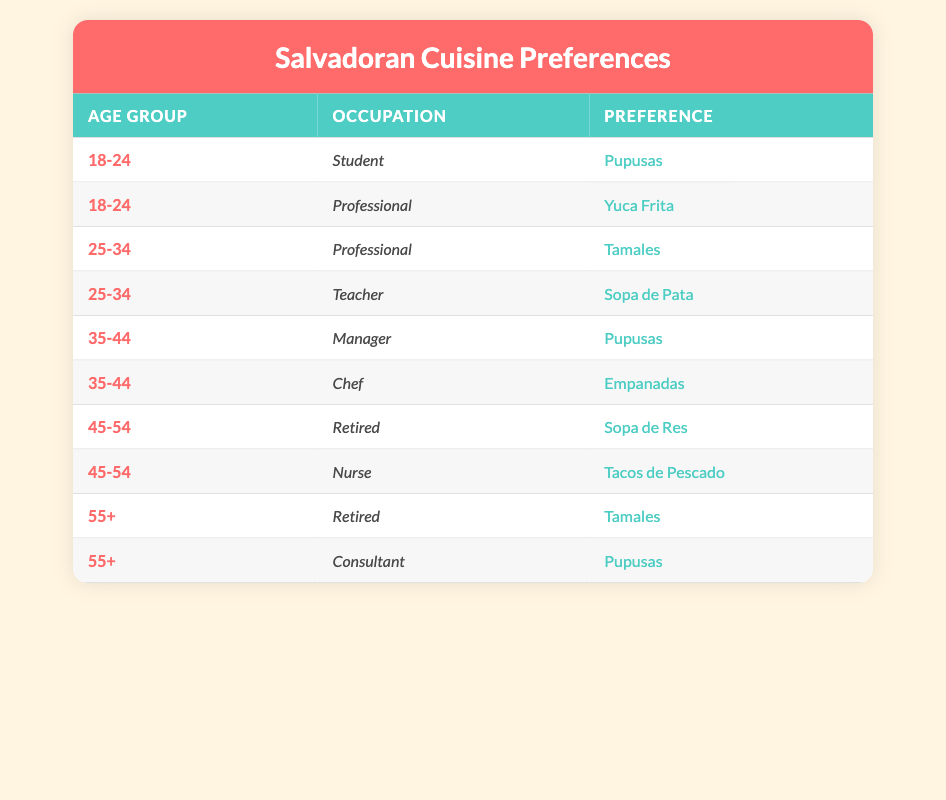What is the most preferred dish among customers aged 35-44? Looking at the preferences listed for the age group 35-44, the dishes are Pupusas and Empanadas. Among these, Pupusas appears first. Therefore, the most preferred dish in this age group is Pupusas.
Answer: Pupusas How many customers aged 55+ prefer Pupusas? In the age group 55+, there are two preferences listed: Tamales and Pupusas. Only one customer, a Consultant, has listed Pupusas as their preference. Hence, there is one customer who prefers Pupusas in this age group.
Answer: 1 Which occupation is associated with Sopa de Res? The occupation associated with Sopa de Res can be found in the table under the age group 45-54. A Retired individual prefers Sopa de Res. Therefore, the occupation related to this dish is Retired.
Answer: Retired Are there any students who prefer Yuca Frita? The table shows that one student aged 18-24 prefers Pupusas and there are no mentions of students preferring Yuca Frita. Thus, there are no students who prefer Yuca Frita.
Answer: No Which age group shows the highest variety of preferences? To find the age group with the highest variety of preferences, we look at the number of different dishes listed in each group: 18-24 has 2, 25-34 has 2, 35-44 has 2, 45-54 has 2, and 55+ has 2. Since all age groups show the same variety of 2 preferences, it means no group exceeds another.
Answer: None What is the total number of distinct dishes preferred by customers aged 35-44? The age group 35-44 has two distinct preferences listed: Pupusas and Empanadas. Therefore, the total number of distinct dishes for this age group is two.
Answer: 2 Which occupation has the least variety of preferred dishes? Analyzing the occupations, we find: Retired okay has 2 dishes (Sopa de Res and Tamales), Manager has 1 dish (Pupusas), Chef has 1 dish (Empanadas), Student has 1 dish (Pupusas), and Professional has 2 dishes (Yuca Frita and Tamales). The occupations that have the least variety, appearing only once, are Manager, Chef, and Student.
Answer: Manager, Chef, Student Are Tamales preferred by any Professional? In the table, only one professional from the age group 25-34 prefers Tamales. Therefore, yes, Tamales is preferred by at least one Professional.
Answer: Yes 